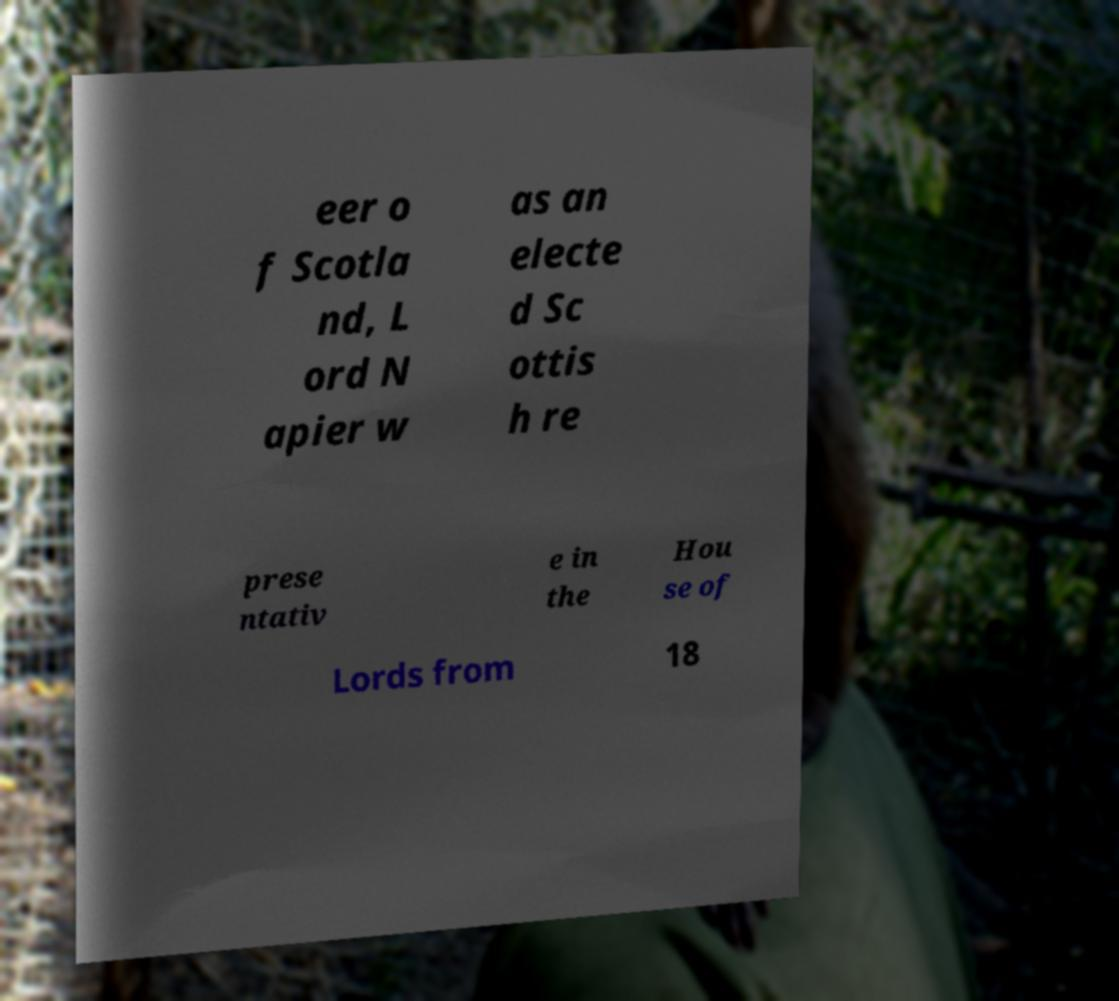Can you accurately transcribe the text from the provided image for me? eer o f Scotla nd, L ord N apier w as an electe d Sc ottis h re prese ntativ e in the Hou se of Lords from 18 